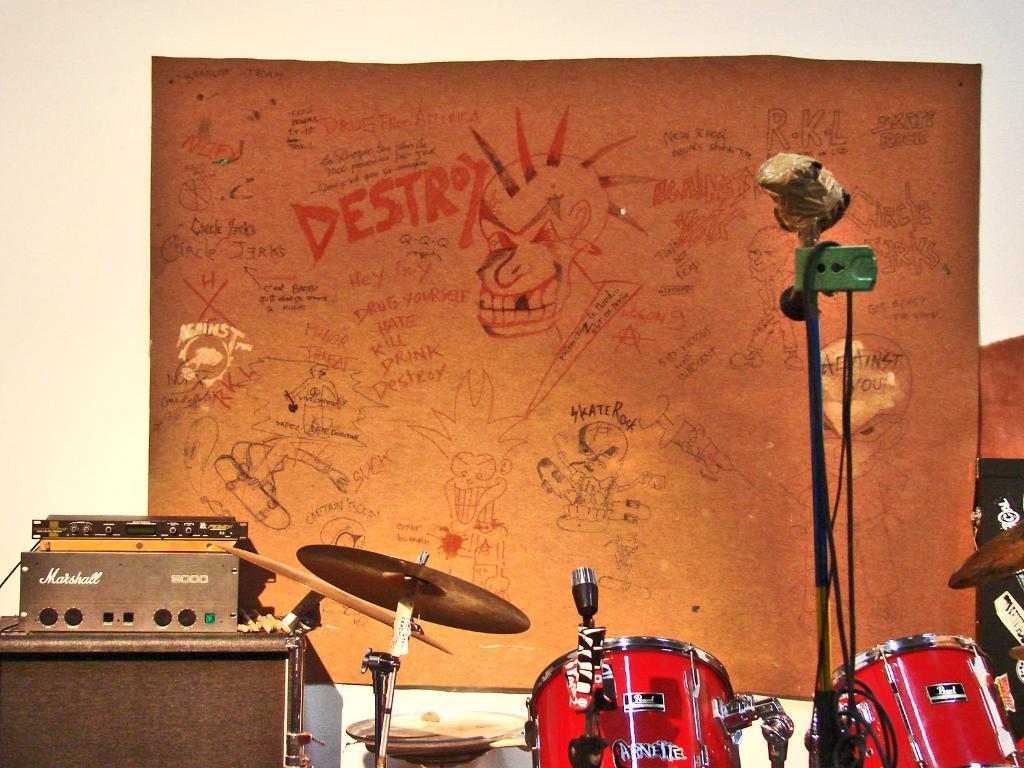Describe this image in one or two sentences. There are few musical instruments and there is an orange color object attached to a wall which has some thing written and drawn on it. 